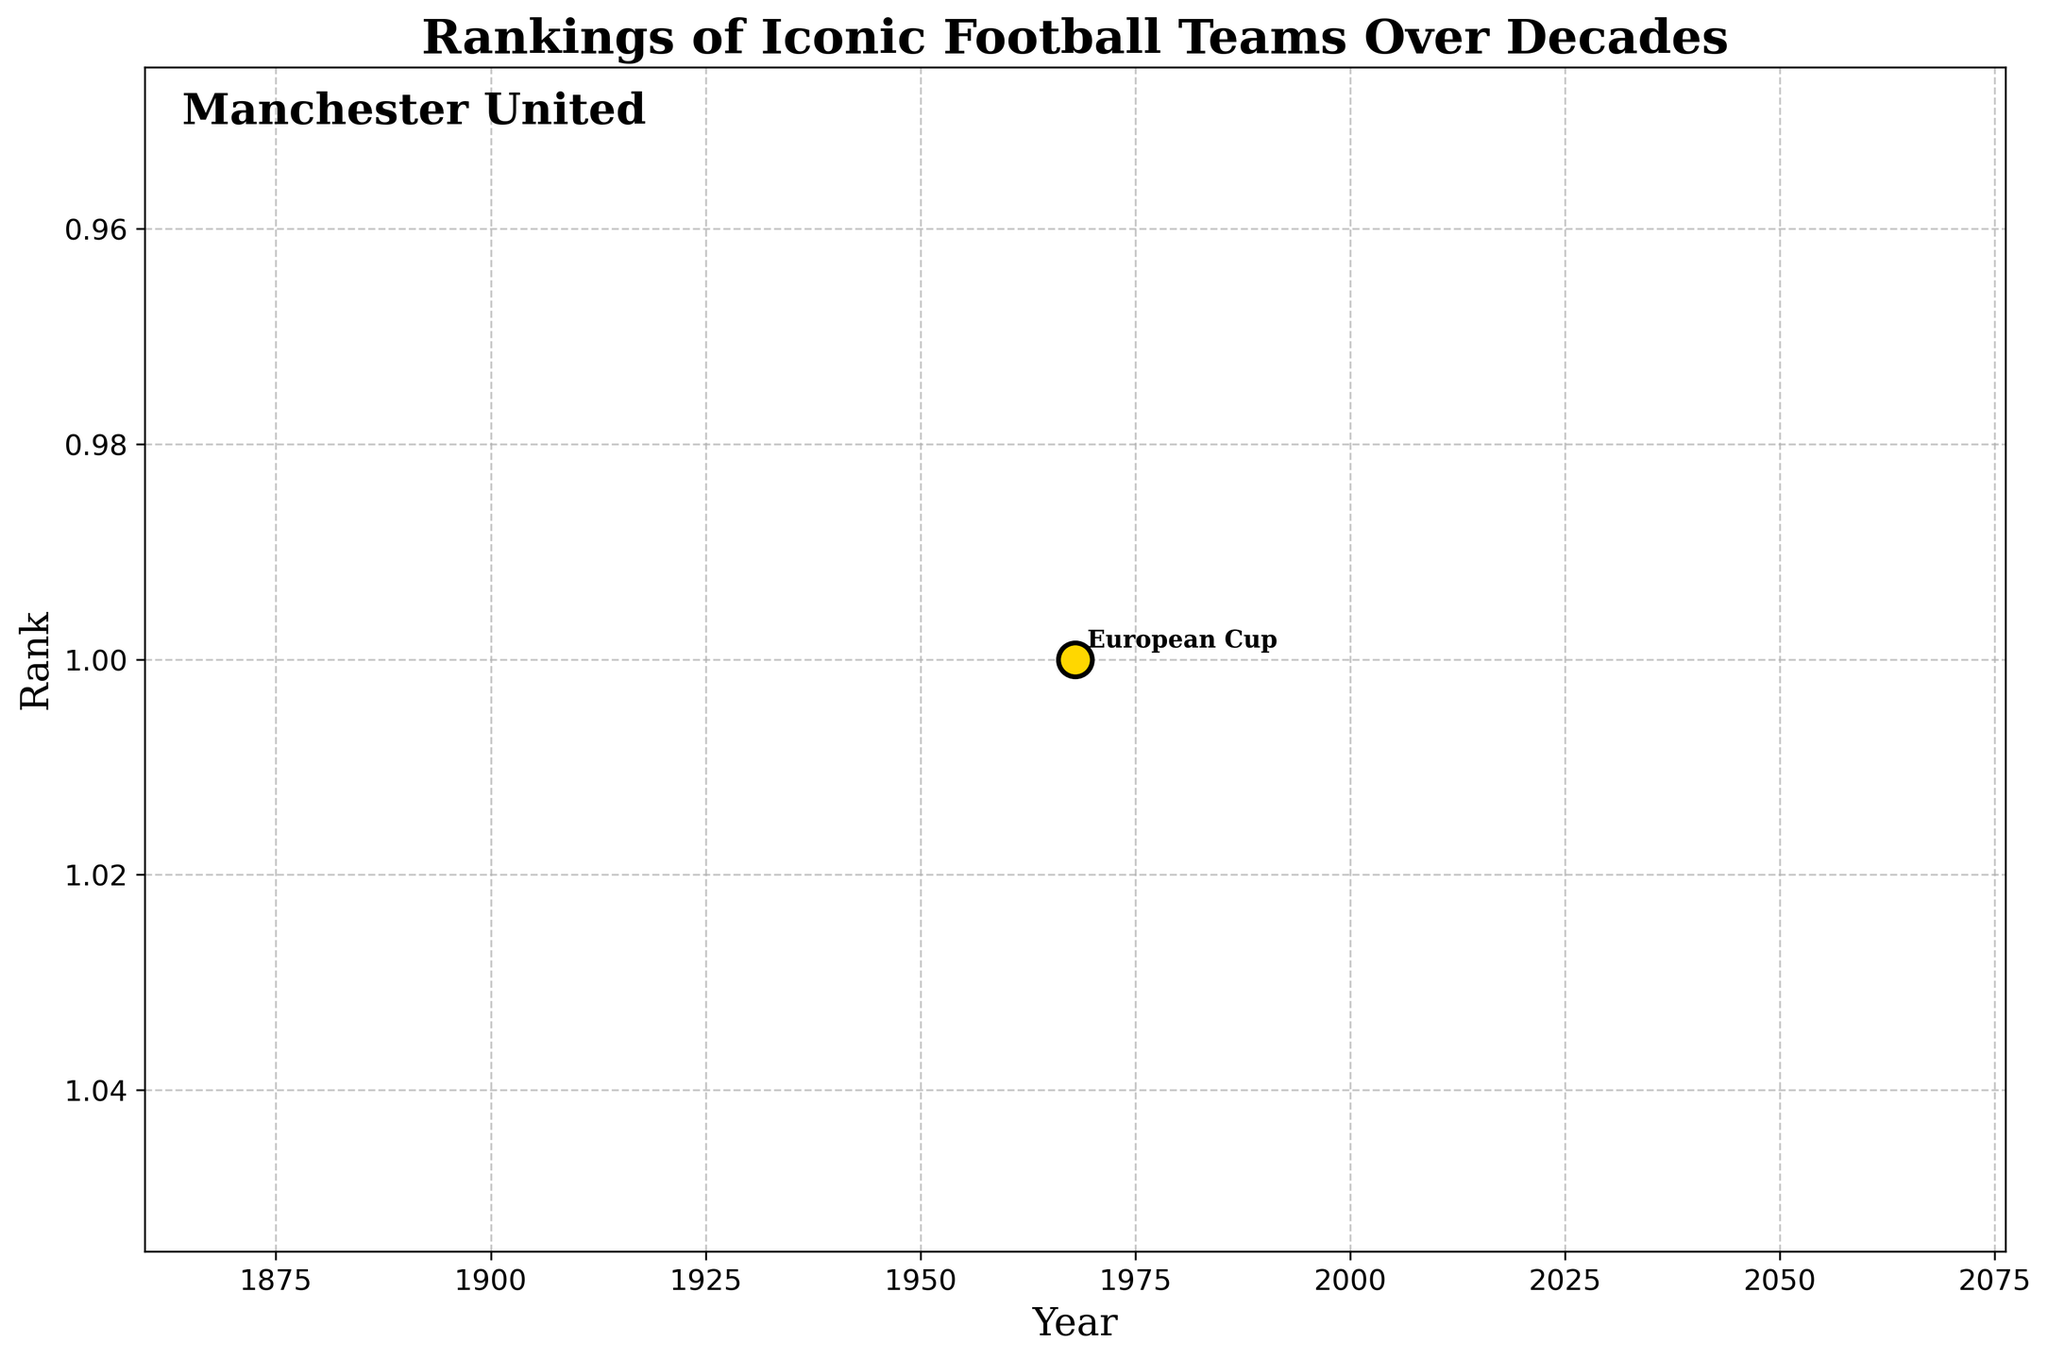What is the title of the plot? The title of the plot is located at the top and is given in large, bold font. It reads "Rankings of Iconic Football Teams Over Decades."
Answer: Rankings of Iconic Football Teams Over Decades What does the y-axis represent? The y-axis, labeled "Rank," shows the ranking positions of Manchester United over the years. The values decrease as you go upward, indicating higher rankings.
Answer: Rank What year is highlighted for a championship win? The year highlighted is indicated by a large gold scatter point with accompanying label text near it. It shows the year 1968.
Answer: 1968 Which team is shown on the plot? The team name is written in large text at the top left corner of the plot. It reads "Manchester United."
Answer: Manchester United What type of championship win is highlighted in 1968? The text annotation next to the gold scatter point for the year 1968 indicates the type of championship win. It reads "European Cup."
Answer: European Cup Does the plot show multiple teams or just one team’s rankings over time? The text on the plot and the single line drawn suggest that it shows the rankings of just one team, Manchester United, over time.
Answer: Just one team What color is used for the scatter points that highlight championship wins? The scatter points highlighting championship wins are in a distinct color different from the line color. They are shown in gold.
Answer: Gold How many years of data are shown in the plot? Referring to the x-axis, you can count the number of years present. In this instance, only the year 1968 is shown.
Answer: One year, 1968 What is the rank of Manchester United in 1968? On the plot, the rank for the year 1968 indicated by the data point is 1. This is also confirmed by the y-axis label "Rank."
Answer: 1 